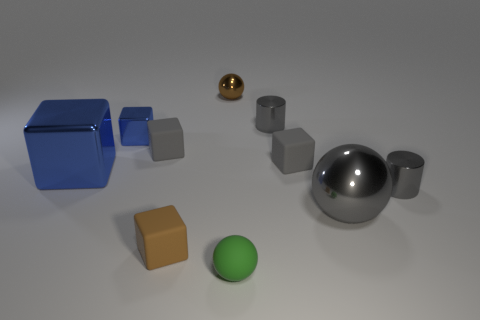Subtract all tiny balls. How many balls are left? 1 Subtract all yellow spheres. How many gray blocks are left? 2 Subtract all brown balls. How many balls are left? 2 Subtract all spheres. How many objects are left? 7 Subtract all brown metallic spheres. Subtract all big metal things. How many objects are left? 7 Add 2 small rubber cubes. How many small rubber cubes are left? 5 Add 6 small green objects. How many small green objects exist? 7 Subtract 1 blue blocks. How many objects are left? 9 Subtract all gray blocks. Subtract all blue cylinders. How many blocks are left? 3 